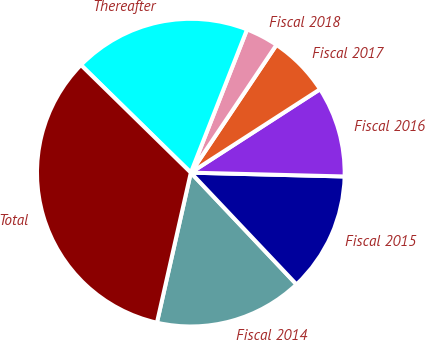Convert chart. <chart><loc_0><loc_0><loc_500><loc_500><pie_chart><fcel>Fiscal 2014<fcel>Fiscal 2015<fcel>Fiscal 2016<fcel>Fiscal 2017<fcel>Fiscal 2018<fcel>Thereafter<fcel>Total<nl><fcel>15.59%<fcel>12.55%<fcel>9.52%<fcel>6.48%<fcel>3.44%<fcel>18.62%<fcel>33.8%<nl></chart> 